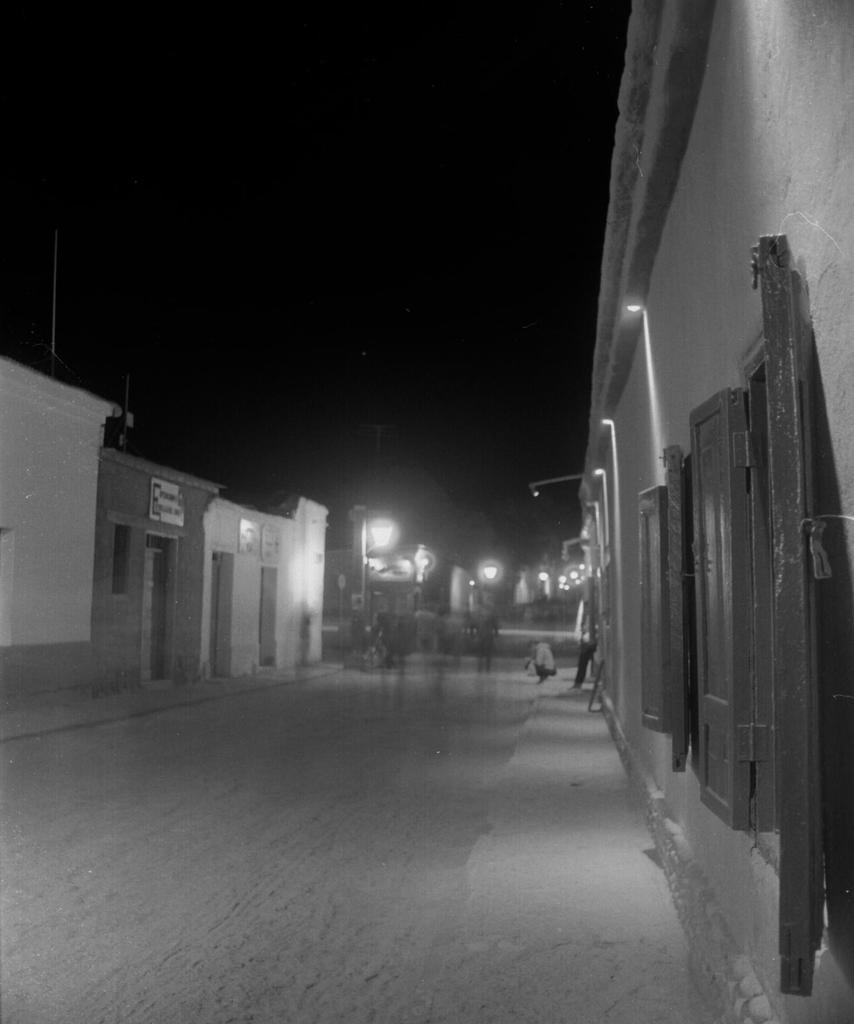What is the person in the image doing? There is a person sitting in the image. What structures can be seen in the image besides the person? There are light poles and buildings in the image. What part of the natural environment is visible in the image? The sky is visible in the image. What is the color scheme of the image? The image is in black and white. How does the person in the image increase the temperature of the room? The person in the image does not have the ability to increase the temperature of the room, as they are just sitting. 